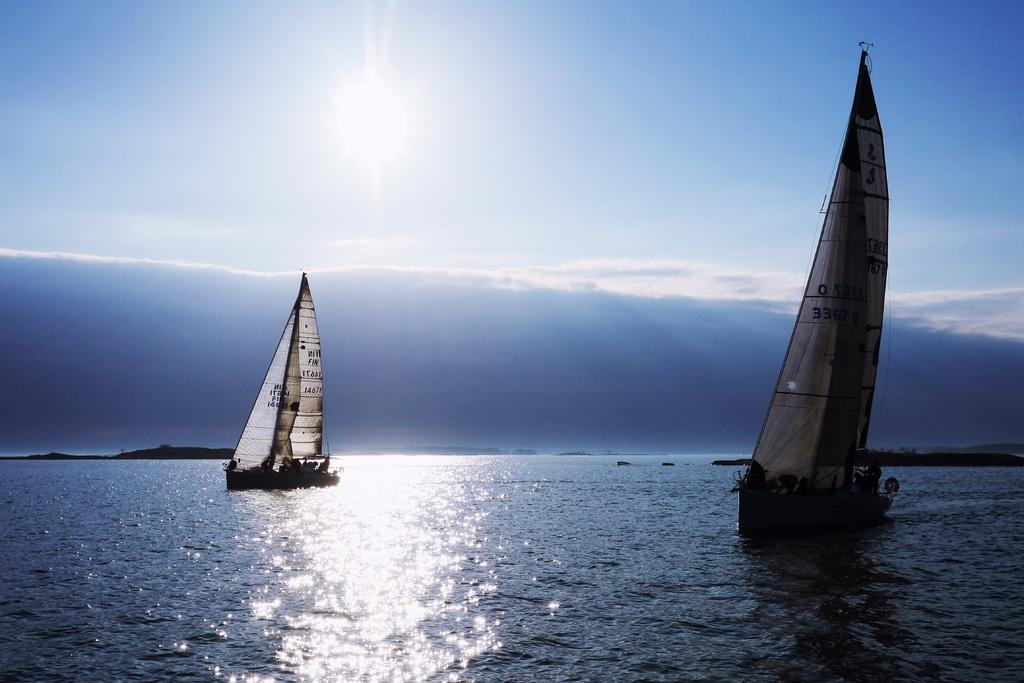How many sailboats are in the image? There are two sailboats in the image. Where are the sailboats located? The sailboats are on the water. What type of water body is depicted in the image? The water appears to be a sea. What else can be seen in the sky in the image? The sky is visible in the image. What is present in the background of the image? There is an island in the background of the image. What type of machine can be seen on the road in the image? There is no machine or road present in the image; it features two sailboats on a sea with an island in the background. 